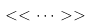<formula> <loc_0><loc_0><loc_500><loc_500>< < \dots > ></formula> 